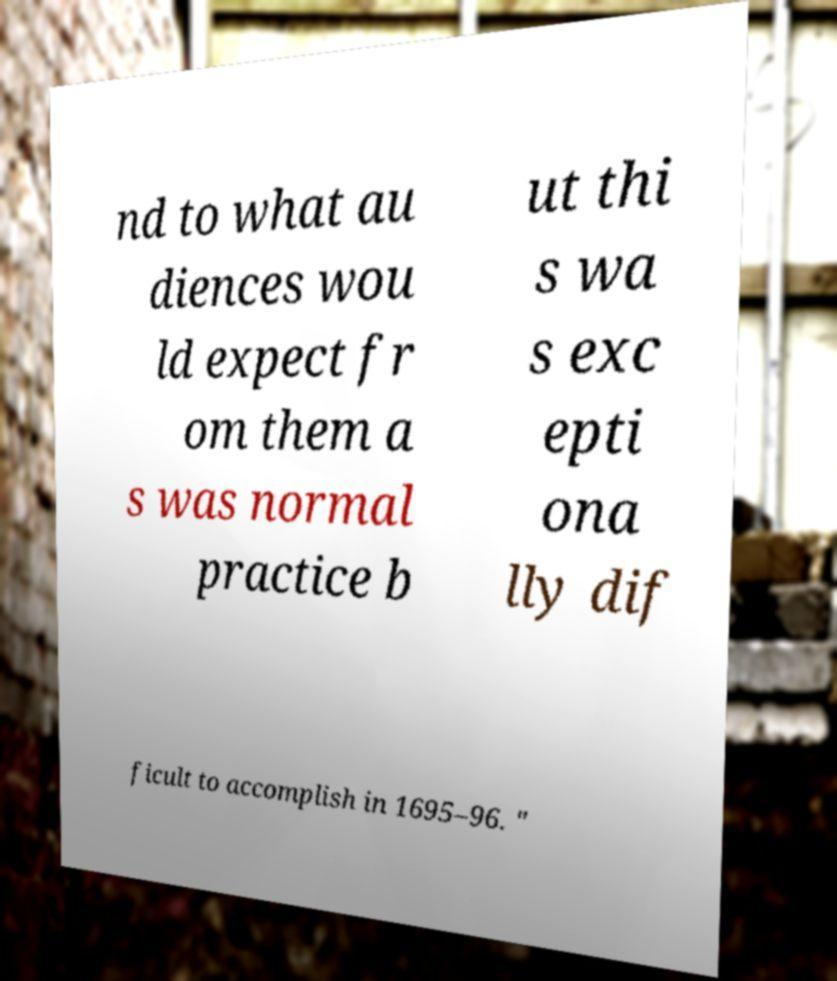What messages or text are displayed in this image? I need them in a readable, typed format. nd to what au diences wou ld expect fr om them a s was normal practice b ut thi s wa s exc epti ona lly dif ficult to accomplish in 1695–96. " 